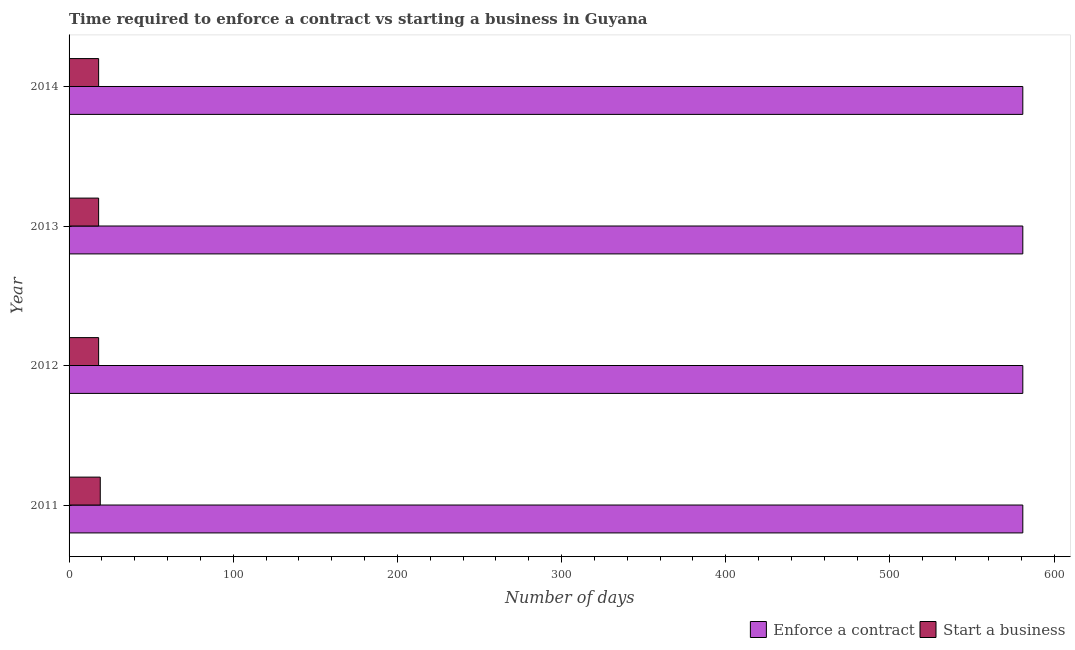How many groups of bars are there?
Your answer should be compact. 4. Are the number of bars per tick equal to the number of legend labels?
Offer a terse response. Yes. Are the number of bars on each tick of the Y-axis equal?
Your response must be concise. Yes. How many bars are there on the 2nd tick from the top?
Make the answer very short. 2. What is the label of the 2nd group of bars from the top?
Your response must be concise. 2013. In how many cases, is the number of bars for a given year not equal to the number of legend labels?
Your answer should be compact. 0. What is the number of days to enforece a contract in 2014?
Give a very brief answer. 581. Across all years, what is the maximum number of days to start a business?
Give a very brief answer. 19. Across all years, what is the minimum number of days to enforece a contract?
Your answer should be compact. 581. In which year was the number of days to enforece a contract maximum?
Provide a short and direct response. 2011. In which year was the number of days to start a business minimum?
Your answer should be compact. 2012. What is the total number of days to start a business in the graph?
Ensure brevity in your answer.  73. What is the difference between the number of days to enforece a contract in 2013 and the number of days to start a business in 2014?
Give a very brief answer. 563. What is the average number of days to start a business per year?
Offer a very short reply. 18.25. In the year 2011, what is the difference between the number of days to start a business and number of days to enforece a contract?
Your answer should be very brief. -562. Is the difference between the number of days to start a business in 2012 and 2014 greater than the difference between the number of days to enforece a contract in 2012 and 2014?
Offer a very short reply. No. What is the difference between the highest and the lowest number of days to start a business?
Make the answer very short. 1. What does the 2nd bar from the top in 2011 represents?
Give a very brief answer. Enforce a contract. What does the 1st bar from the bottom in 2014 represents?
Offer a terse response. Enforce a contract. How many bars are there?
Provide a short and direct response. 8. What is the difference between two consecutive major ticks on the X-axis?
Make the answer very short. 100. Are the values on the major ticks of X-axis written in scientific E-notation?
Make the answer very short. No. How many legend labels are there?
Your answer should be very brief. 2. How are the legend labels stacked?
Keep it short and to the point. Horizontal. What is the title of the graph?
Your answer should be very brief. Time required to enforce a contract vs starting a business in Guyana. Does "Exports" appear as one of the legend labels in the graph?
Ensure brevity in your answer.  No. What is the label or title of the X-axis?
Ensure brevity in your answer.  Number of days. What is the Number of days in Enforce a contract in 2011?
Ensure brevity in your answer.  581. What is the Number of days of Enforce a contract in 2012?
Offer a very short reply. 581. What is the Number of days in Enforce a contract in 2013?
Offer a very short reply. 581. What is the Number of days of Start a business in 2013?
Provide a succinct answer. 18. What is the Number of days of Enforce a contract in 2014?
Keep it short and to the point. 581. What is the Number of days in Start a business in 2014?
Your answer should be compact. 18. Across all years, what is the maximum Number of days of Enforce a contract?
Your answer should be compact. 581. Across all years, what is the minimum Number of days of Enforce a contract?
Offer a very short reply. 581. Across all years, what is the minimum Number of days in Start a business?
Ensure brevity in your answer.  18. What is the total Number of days of Enforce a contract in the graph?
Ensure brevity in your answer.  2324. What is the total Number of days of Start a business in the graph?
Keep it short and to the point. 73. What is the difference between the Number of days of Enforce a contract in 2011 and that in 2012?
Give a very brief answer. 0. What is the difference between the Number of days in Enforce a contract in 2012 and that in 2013?
Keep it short and to the point. 0. What is the difference between the Number of days of Start a business in 2012 and that in 2013?
Keep it short and to the point. 0. What is the difference between the Number of days in Enforce a contract in 2011 and the Number of days in Start a business in 2012?
Offer a very short reply. 563. What is the difference between the Number of days in Enforce a contract in 2011 and the Number of days in Start a business in 2013?
Offer a very short reply. 563. What is the difference between the Number of days in Enforce a contract in 2011 and the Number of days in Start a business in 2014?
Your answer should be very brief. 563. What is the difference between the Number of days of Enforce a contract in 2012 and the Number of days of Start a business in 2013?
Ensure brevity in your answer.  563. What is the difference between the Number of days of Enforce a contract in 2012 and the Number of days of Start a business in 2014?
Your response must be concise. 563. What is the difference between the Number of days in Enforce a contract in 2013 and the Number of days in Start a business in 2014?
Give a very brief answer. 563. What is the average Number of days of Enforce a contract per year?
Provide a succinct answer. 581. What is the average Number of days of Start a business per year?
Offer a terse response. 18.25. In the year 2011, what is the difference between the Number of days in Enforce a contract and Number of days in Start a business?
Make the answer very short. 562. In the year 2012, what is the difference between the Number of days in Enforce a contract and Number of days in Start a business?
Your answer should be very brief. 563. In the year 2013, what is the difference between the Number of days in Enforce a contract and Number of days in Start a business?
Give a very brief answer. 563. In the year 2014, what is the difference between the Number of days in Enforce a contract and Number of days in Start a business?
Provide a succinct answer. 563. What is the ratio of the Number of days of Enforce a contract in 2011 to that in 2012?
Your answer should be very brief. 1. What is the ratio of the Number of days in Start a business in 2011 to that in 2012?
Provide a short and direct response. 1.06. What is the ratio of the Number of days in Enforce a contract in 2011 to that in 2013?
Your response must be concise. 1. What is the ratio of the Number of days in Start a business in 2011 to that in 2013?
Give a very brief answer. 1.06. What is the ratio of the Number of days in Enforce a contract in 2011 to that in 2014?
Your answer should be very brief. 1. What is the ratio of the Number of days of Start a business in 2011 to that in 2014?
Ensure brevity in your answer.  1.06. What is the ratio of the Number of days of Enforce a contract in 2012 to that in 2013?
Make the answer very short. 1. What is the ratio of the Number of days of Enforce a contract in 2013 to that in 2014?
Keep it short and to the point. 1. What is the ratio of the Number of days of Start a business in 2013 to that in 2014?
Your response must be concise. 1. What is the difference between the highest and the lowest Number of days of Enforce a contract?
Offer a terse response. 0. What is the difference between the highest and the lowest Number of days in Start a business?
Provide a succinct answer. 1. 